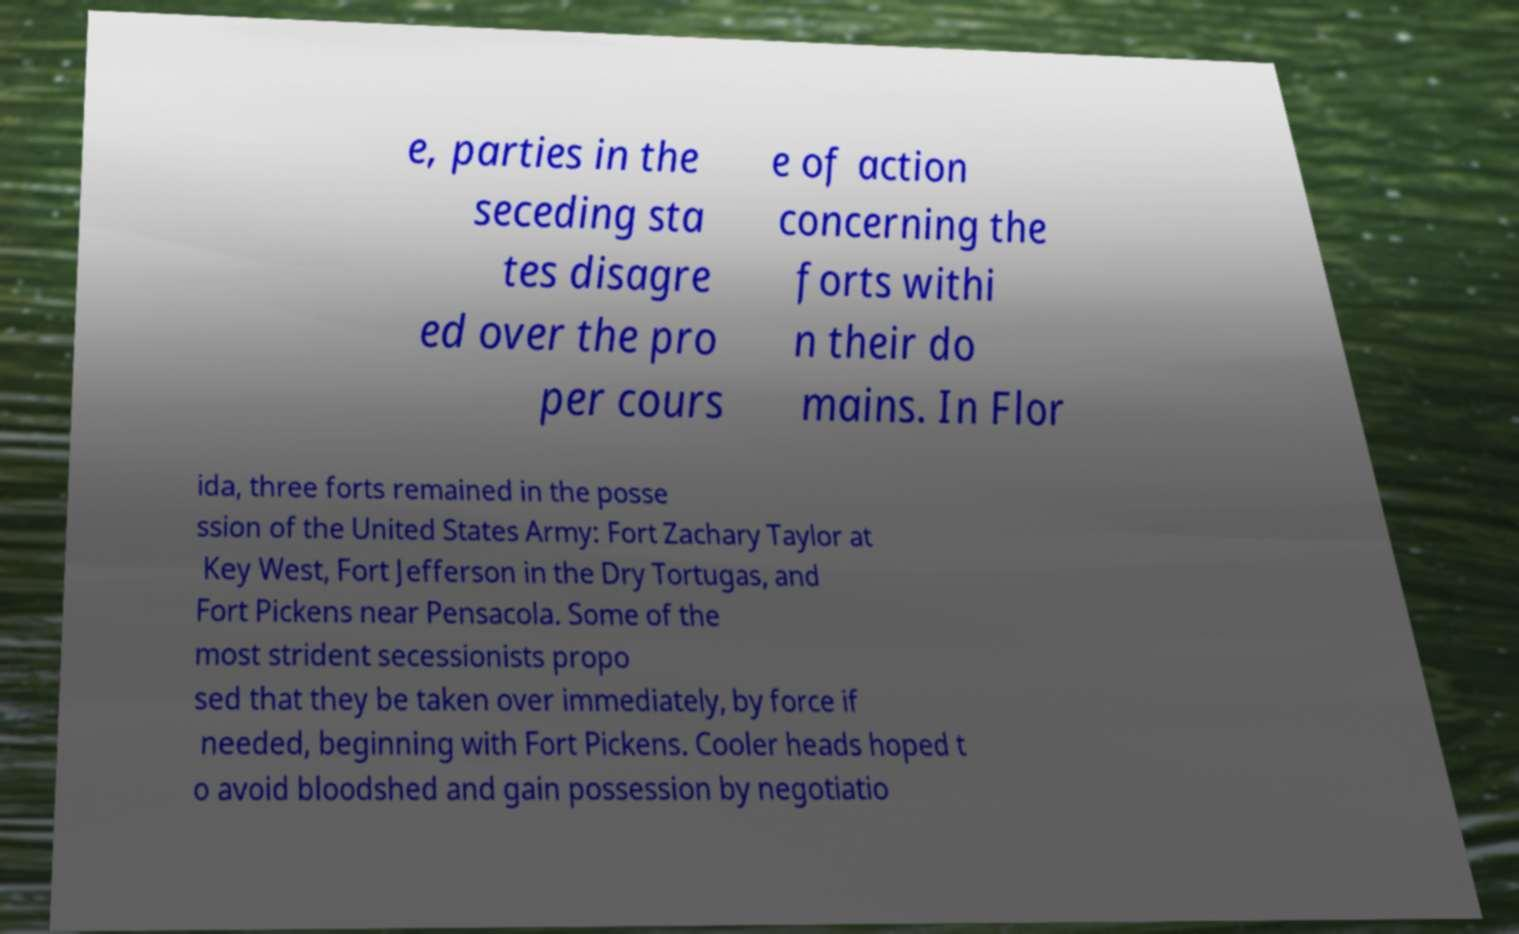For documentation purposes, I need the text within this image transcribed. Could you provide that? e, parties in the seceding sta tes disagre ed over the pro per cours e of action concerning the forts withi n their do mains. In Flor ida, three forts remained in the posse ssion of the United States Army: Fort Zachary Taylor at Key West, Fort Jefferson in the Dry Tortugas, and Fort Pickens near Pensacola. Some of the most strident secessionists propo sed that they be taken over immediately, by force if needed, beginning with Fort Pickens. Cooler heads hoped t o avoid bloodshed and gain possession by negotiatio 